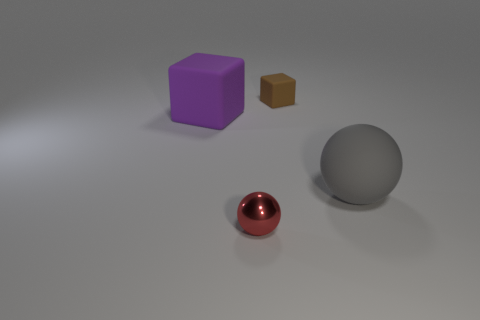The tiny thing that is to the left of the rubber block on the right side of the large matte thing behind the gray rubber ball is made of what material?
Ensure brevity in your answer.  Metal. Are there any gray objects that have the same shape as the small brown matte thing?
Your answer should be compact. No. What shape is the red shiny object that is the same size as the brown thing?
Offer a terse response. Sphere. What number of objects are both behind the small red metallic sphere and to the right of the purple thing?
Keep it short and to the point. 2. Is the number of tiny matte objects that are in front of the big purple rubber object less than the number of yellow metal blocks?
Provide a short and direct response. No. Are there any red things of the same size as the brown rubber cube?
Give a very brief answer. Yes. What color is the block that is made of the same material as the tiny brown thing?
Offer a terse response. Purple. How many big matte balls are to the right of the big matte thing that is to the left of the small brown thing?
Keep it short and to the point. 1. What material is the object that is to the right of the big purple thing and on the left side of the small brown matte object?
Provide a short and direct response. Metal. There is a big thing that is on the left side of the small block; does it have the same shape as the brown matte object?
Your response must be concise. Yes. 